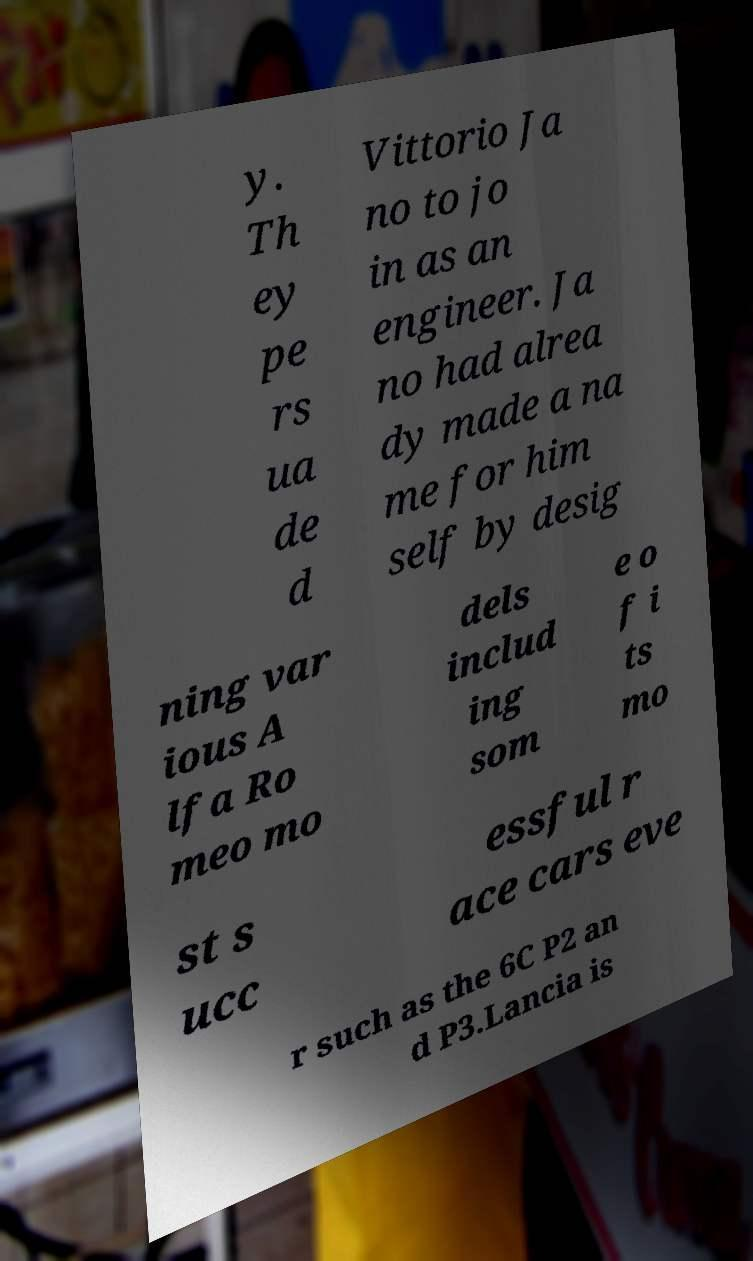What messages or text are displayed in this image? I need them in a readable, typed format. y. Th ey pe rs ua de d Vittorio Ja no to jo in as an engineer. Ja no had alrea dy made a na me for him self by desig ning var ious A lfa Ro meo mo dels includ ing som e o f i ts mo st s ucc essful r ace cars eve r such as the 6C P2 an d P3.Lancia is 